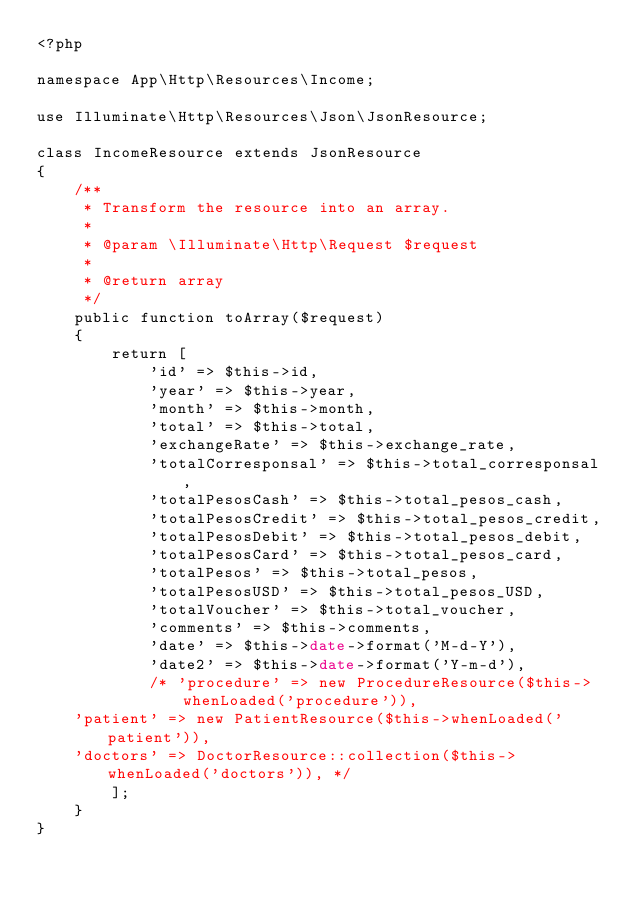Convert code to text. <code><loc_0><loc_0><loc_500><loc_500><_PHP_><?php

namespace App\Http\Resources\Income;

use Illuminate\Http\Resources\Json\JsonResource;

class IncomeResource extends JsonResource
{
    /**
     * Transform the resource into an array.
     *
     * @param \Illuminate\Http\Request $request
     *
     * @return array
     */
    public function toArray($request)
    {
        return [
            'id' => $this->id,
            'year' => $this->year,
            'month' => $this->month,
            'total' => $this->total,
            'exchangeRate' => $this->exchange_rate,
            'totalCorresponsal' => $this->total_corresponsal,
            'totalPesosCash' => $this->total_pesos_cash,
            'totalPesosCredit' => $this->total_pesos_credit,
            'totalPesosDebit' => $this->total_pesos_debit,
            'totalPesosCard' => $this->total_pesos_card,
            'totalPesos' => $this->total_pesos,
            'totalPesosUSD' => $this->total_pesos_USD,
            'totalVoucher' => $this->total_voucher,
            'comments' => $this->comments,
            'date' => $this->date->format('M-d-Y'),
            'date2' => $this->date->format('Y-m-d'),
            /* 'procedure' => new ProcedureResource($this->whenLoaded('procedure')),
    'patient' => new PatientResource($this->whenLoaded('patient')),
    'doctors' => DoctorResource::collection($this->whenLoaded('doctors')), */
        ];
    }
}</code> 